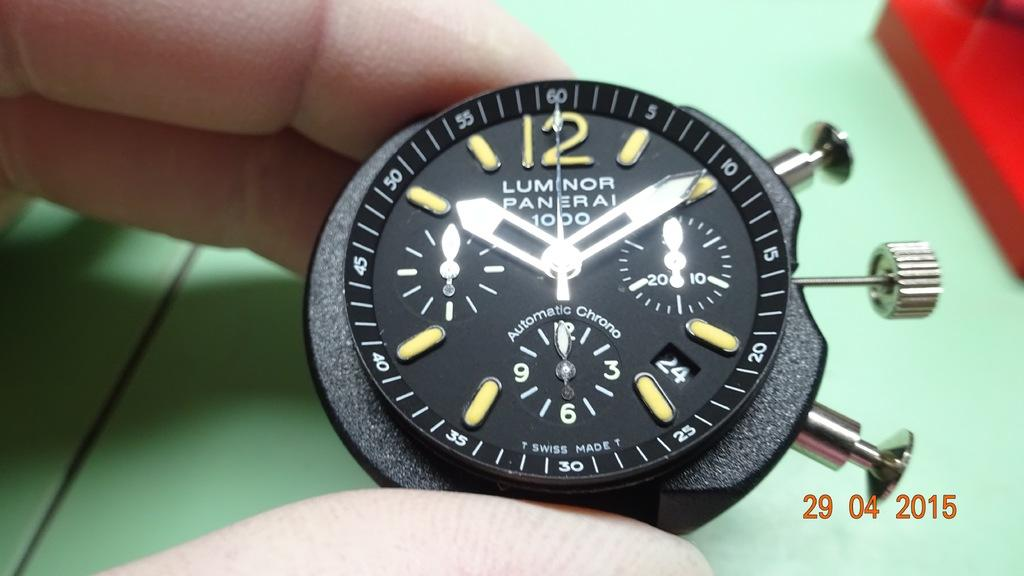<image>
Create a compact narrative representing the image presented. Person holding a black and yellow wristwatch which says Luminor Panerai on it. 